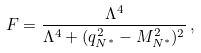<formula> <loc_0><loc_0><loc_500><loc_500>F = \frac { \Lambda ^ { 4 } } { \Lambda ^ { 4 } + ( q _ { N ^ { * } } ^ { 2 } - M _ { N ^ { * } } ^ { 2 } ) ^ { 2 } } \, ,</formula> 